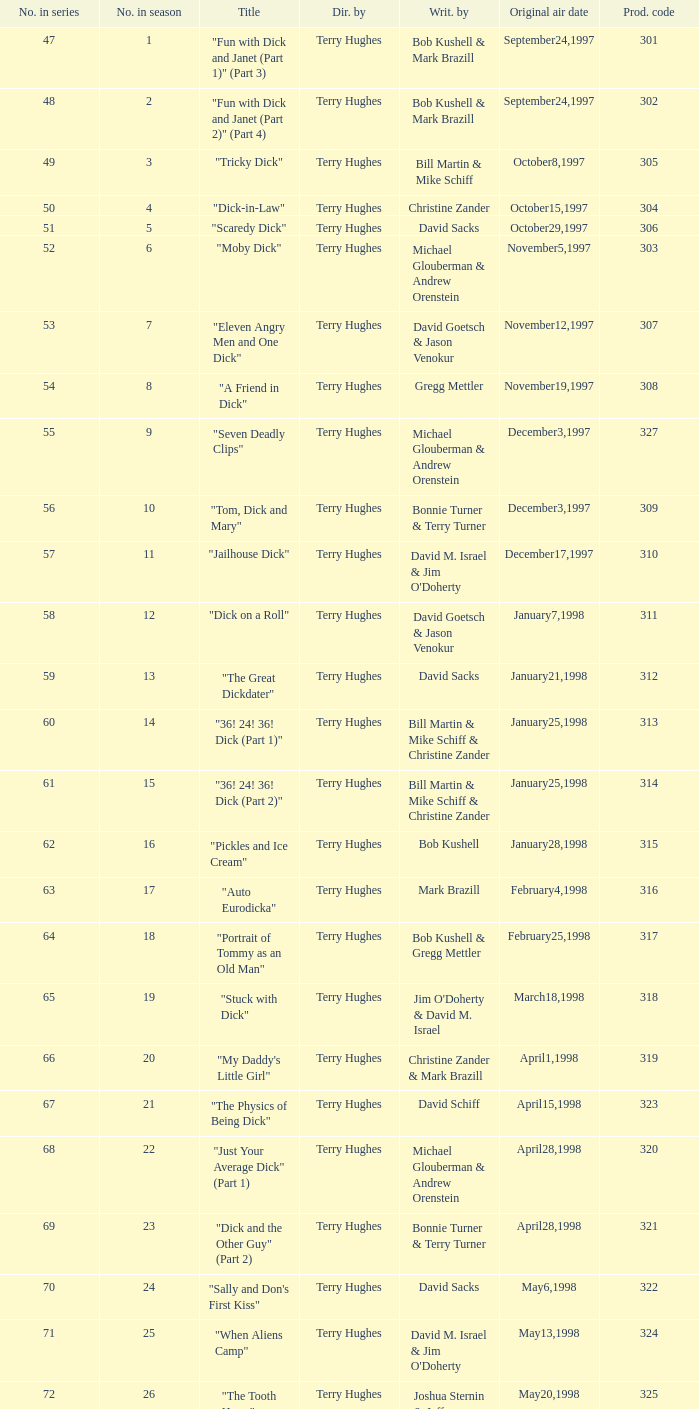What is the title of episode 10? "Tom, Dick and Mary". 